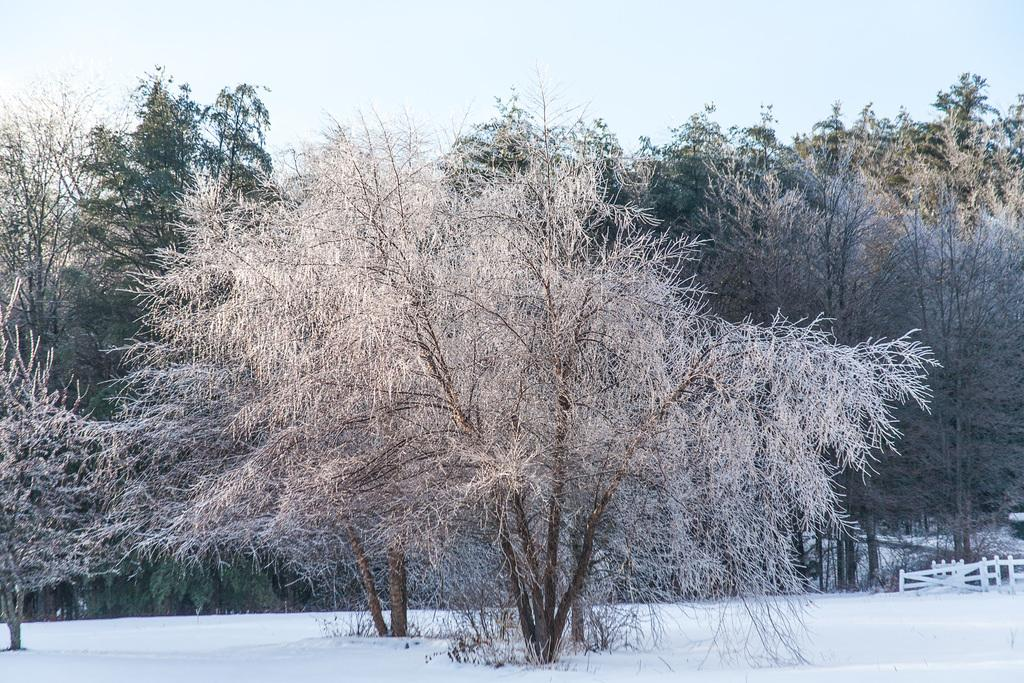What type of vegetation can be seen in the image? There are trees in the image. What is visible at the top of the image? The sky is visible at the top of the image. What material is covering the ground at the bottom of the image? There are railings on the snow at the bottom of the image. How much pleasure can be derived from the amount of snow in the image? The image does not convey any information about the amount of pleasure that can be derived from the snow, nor does it provide any information about the amount of snow present. 